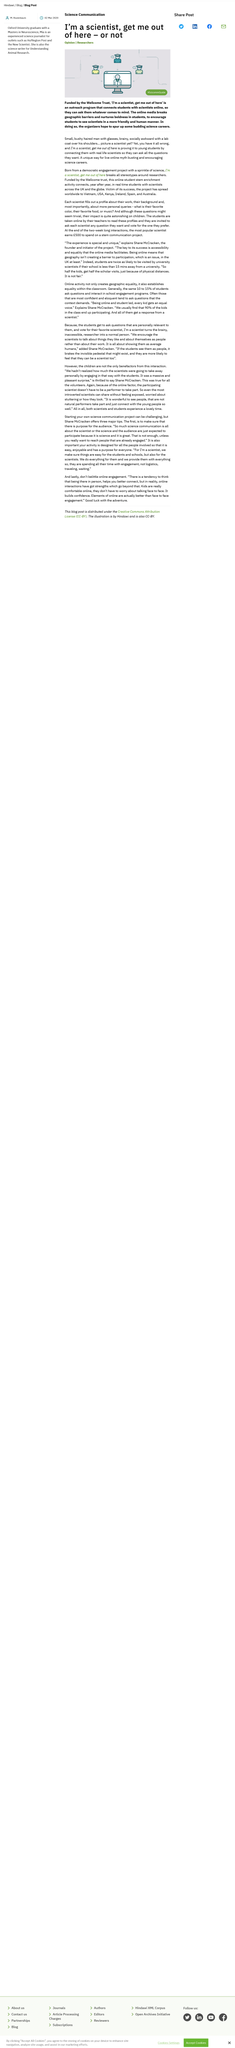Identify some key points in this picture. The organization 'I'm a scientist, get me out of here' is funded by the Wellcome Trust. The 'I'm a Scientist, Get Me Out of Here' program provides a valuable service by connecting young students with scientists, allowing them to ask scientific questions and gain insight into the world of science. The project has been implemented in multiple countries, including the United Kingdom, Vietnam, the United States, Kenya, Ireland, Spain, and Australia. 